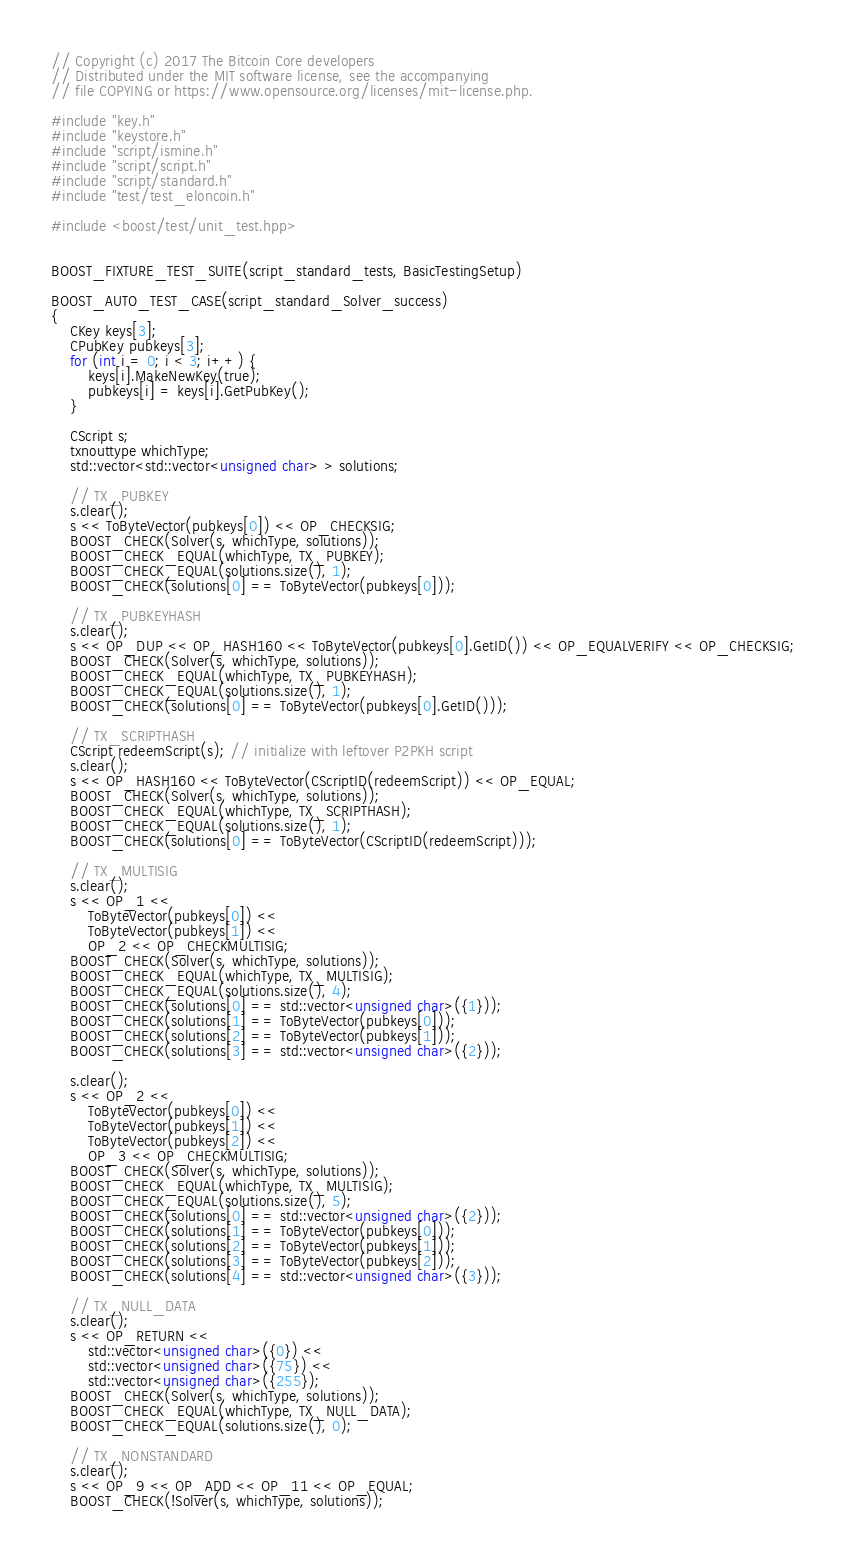<code> <loc_0><loc_0><loc_500><loc_500><_C++_>// Copyright (c) 2017 The Bitcoin Core developers
// Distributed under the MIT software license, see the accompanying
// file COPYING or https://www.opensource.org/licenses/mit-license.php.

#include "key.h"
#include "keystore.h"
#include "script/ismine.h"
#include "script/script.h"
#include "script/standard.h"
#include "test/test_eloncoin.h"

#include <boost/test/unit_test.hpp>


BOOST_FIXTURE_TEST_SUITE(script_standard_tests, BasicTestingSetup)

BOOST_AUTO_TEST_CASE(script_standard_Solver_success)
{
    CKey keys[3];
    CPubKey pubkeys[3];
    for (int i = 0; i < 3; i++) {
        keys[i].MakeNewKey(true);
        pubkeys[i] = keys[i].GetPubKey();
    }

    CScript s;
    txnouttype whichType;
    std::vector<std::vector<unsigned char> > solutions;

    // TX_PUBKEY
    s.clear();
    s << ToByteVector(pubkeys[0]) << OP_CHECKSIG;
    BOOST_CHECK(Solver(s, whichType, solutions));
    BOOST_CHECK_EQUAL(whichType, TX_PUBKEY);
    BOOST_CHECK_EQUAL(solutions.size(), 1);
    BOOST_CHECK(solutions[0] == ToByteVector(pubkeys[0]));

    // TX_PUBKEYHASH
    s.clear();
    s << OP_DUP << OP_HASH160 << ToByteVector(pubkeys[0].GetID()) << OP_EQUALVERIFY << OP_CHECKSIG;
    BOOST_CHECK(Solver(s, whichType, solutions));
    BOOST_CHECK_EQUAL(whichType, TX_PUBKEYHASH);
    BOOST_CHECK_EQUAL(solutions.size(), 1);
    BOOST_CHECK(solutions[0] == ToByteVector(pubkeys[0].GetID()));

    // TX_SCRIPTHASH
    CScript redeemScript(s); // initialize with leftover P2PKH script
    s.clear();
    s << OP_HASH160 << ToByteVector(CScriptID(redeemScript)) << OP_EQUAL;
    BOOST_CHECK(Solver(s, whichType, solutions));
    BOOST_CHECK_EQUAL(whichType, TX_SCRIPTHASH);
    BOOST_CHECK_EQUAL(solutions.size(), 1);
    BOOST_CHECK(solutions[0] == ToByteVector(CScriptID(redeemScript)));

    // TX_MULTISIG
    s.clear();
    s << OP_1 <<
        ToByteVector(pubkeys[0]) <<
        ToByteVector(pubkeys[1]) <<
        OP_2 << OP_CHECKMULTISIG;
    BOOST_CHECK(Solver(s, whichType, solutions));
    BOOST_CHECK_EQUAL(whichType, TX_MULTISIG);
    BOOST_CHECK_EQUAL(solutions.size(), 4);
    BOOST_CHECK(solutions[0] == std::vector<unsigned char>({1}));
    BOOST_CHECK(solutions[1] == ToByteVector(pubkeys[0]));
    BOOST_CHECK(solutions[2] == ToByteVector(pubkeys[1]));
    BOOST_CHECK(solutions[3] == std::vector<unsigned char>({2}));

    s.clear();
    s << OP_2 <<
        ToByteVector(pubkeys[0]) <<
        ToByteVector(pubkeys[1]) <<
        ToByteVector(pubkeys[2]) <<
        OP_3 << OP_CHECKMULTISIG;
    BOOST_CHECK(Solver(s, whichType, solutions));
    BOOST_CHECK_EQUAL(whichType, TX_MULTISIG);
    BOOST_CHECK_EQUAL(solutions.size(), 5);
    BOOST_CHECK(solutions[0] == std::vector<unsigned char>({2}));
    BOOST_CHECK(solutions[1] == ToByteVector(pubkeys[0]));
    BOOST_CHECK(solutions[2] == ToByteVector(pubkeys[1]));
    BOOST_CHECK(solutions[3] == ToByteVector(pubkeys[2]));
    BOOST_CHECK(solutions[4] == std::vector<unsigned char>({3}));

    // TX_NULL_DATA
    s.clear();
    s << OP_RETURN <<
        std::vector<unsigned char>({0}) <<
        std::vector<unsigned char>({75}) <<
        std::vector<unsigned char>({255});
    BOOST_CHECK(Solver(s, whichType, solutions));
    BOOST_CHECK_EQUAL(whichType, TX_NULL_DATA);
    BOOST_CHECK_EQUAL(solutions.size(), 0);

    // TX_NONSTANDARD
    s.clear();
    s << OP_9 << OP_ADD << OP_11 << OP_EQUAL;
    BOOST_CHECK(!Solver(s, whichType, solutions));</code> 